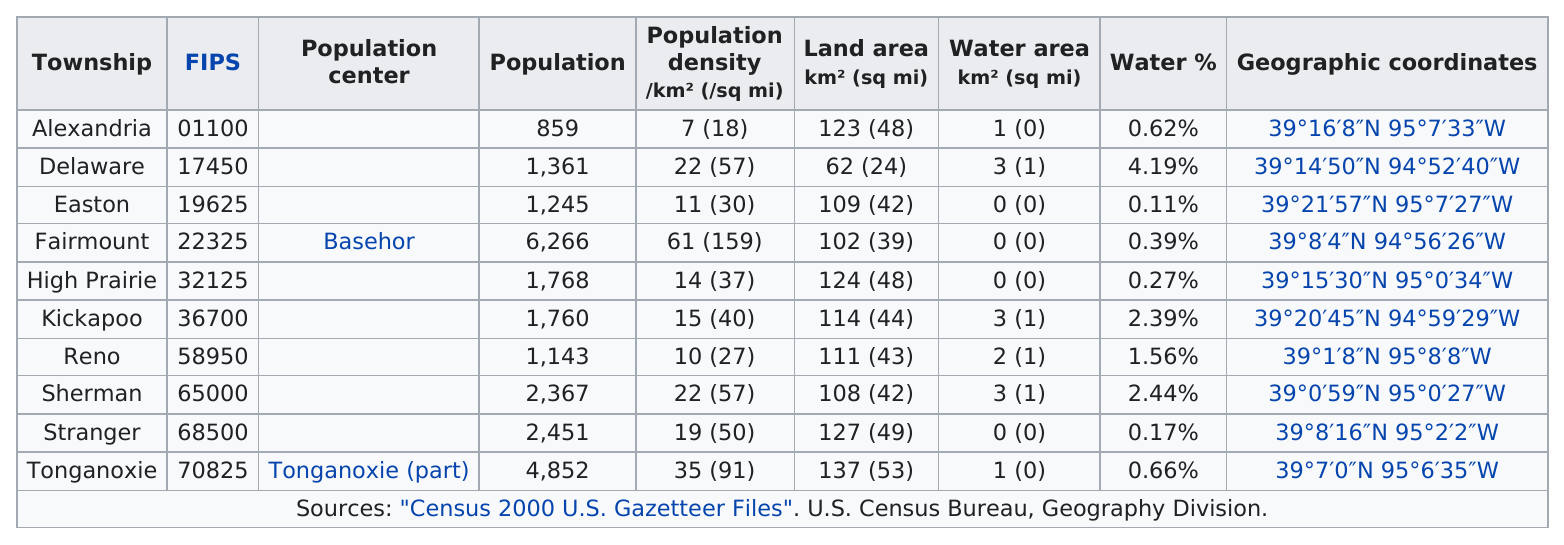Mention a couple of crucial points in this snapshot. The township with the largest population is Fairmount. Alexandria County has a lower population than Delaware County. There are 4 townships in the United States with a population greater than 2,000. Delaware's land area was above 45 square miles. The population difference between Easton and Reno is 102. 